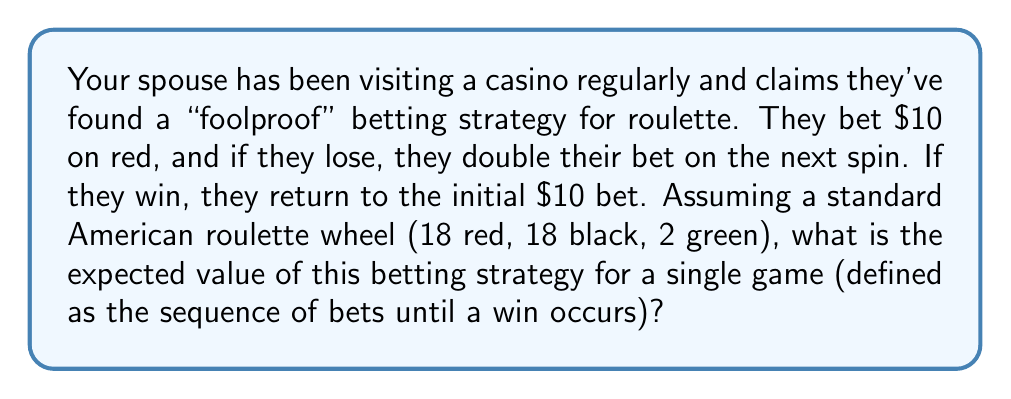Give your solution to this math problem. Let's approach this step-by-step:

1) First, we need to calculate the probability of winning on each spin:
   $P(\text{win}) = \frac{18}{38} \approx 0.4737$
   $P(\text{lose}) = \frac{20}{38} \approx 0.5263$

2) Now, let's consider the possible outcomes:

   - Win on 1st spin: Probability = $\frac{18}{38}$, Profit = $10
   - Win on 2nd spin: Probability = $\frac{20}{38} \cdot \frac{18}{38}$, Profit = $20 - 10 = 10$
   - Win on 3rd spin: Probability = $(\frac{20}{38})^2 \cdot \frac{18}{38}$, Profit = $40 - 10 - 20 = 10$
   - And so on...

3) We can see that regardless of which spin we win on, the profit is always $10. The expected value is thus:

   $$E = 10 \cdot (\frac{18}{38} + \frac{20}{38} \cdot \frac{18}{38} + (\frac{20}{38})^2 \cdot \frac{18}{38} + ...)$$

4) This is a geometric series with first term $a = \frac{18}{38}$ and common ratio $r = \frac{20}{38}$. The sum of this infinite series is:

   $$S_{\infty} = \frac{a}{1-r} = \frac{\frac{18}{38}}{1-\frac{20}{38}} = \frac{\frac{18}{38}}{\frac{18}{38}} = 1$$

5) Therefore, the expected value is:

   $$E = 10 \cdot 1 = 10$$

However, it's crucial to note that this expected value is theoretical and assumes unlimited funds and no table limits, which is unrealistic in practice.
Answer: The expected value of this betting strategy for a single game is $10. 